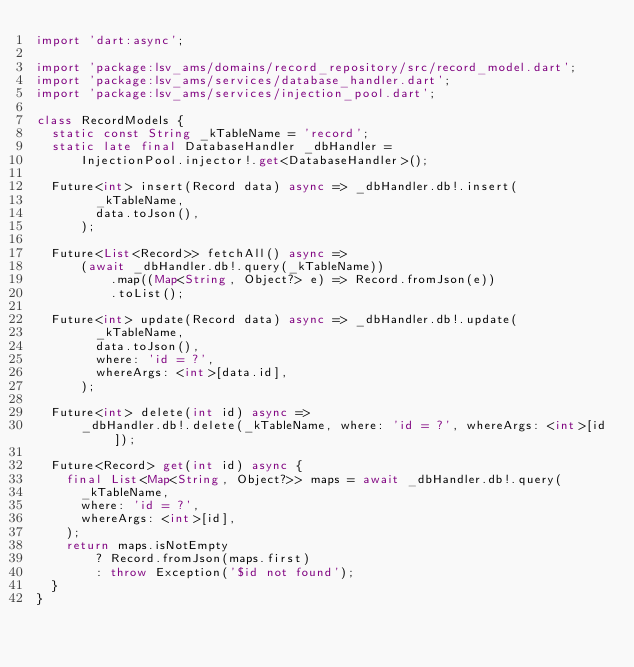<code> <loc_0><loc_0><loc_500><loc_500><_Dart_>import 'dart:async';

import 'package:lsv_ams/domains/record_repository/src/record_model.dart';
import 'package:lsv_ams/services/database_handler.dart';
import 'package:lsv_ams/services/injection_pool.dart';

class RecordModels {
  static const String _kTableName = 'record';
  static late final DatabaseHandler _dbHandler =
      InjectionPool.injector!.get<DatabaseHandler>();

  Future<int> insert(Record data) async => _dbHandler.db!.insert(
        _kTableName,
        data.toJson(),
      );

  Future<List<Record>> fetchAll() async =>
      (await _dbHandler.db!.query(_kTableName))
          .map((Map<String, Object?> e) => Record.fromJson(e))
          .toList();

  Future<int> update(Record data) async => _dbHandler.db!.update(
        _kTableName,
        data.toJson(),
        where: 'id = ?',
        whereArgs: <int>[data.id],
      );

  Future<int> delete(int id) async =>
      _dbHandler.db!.delete(_kTableName, where: 'id = ?', whereArgs: <int>[id]);

  Future<Record> get(int id) async {
    final List<Map<String, Object?>> maps = await _dbHandler.db!.query(
      _kTableName,
      where: 'id = ?',
      whereArgs: <int>[id],
    );
    return maps.isNotEmpty
        ? Record.fromJson(maps.first)
        : throw Exception('$id not found');
  }
}
</code> 